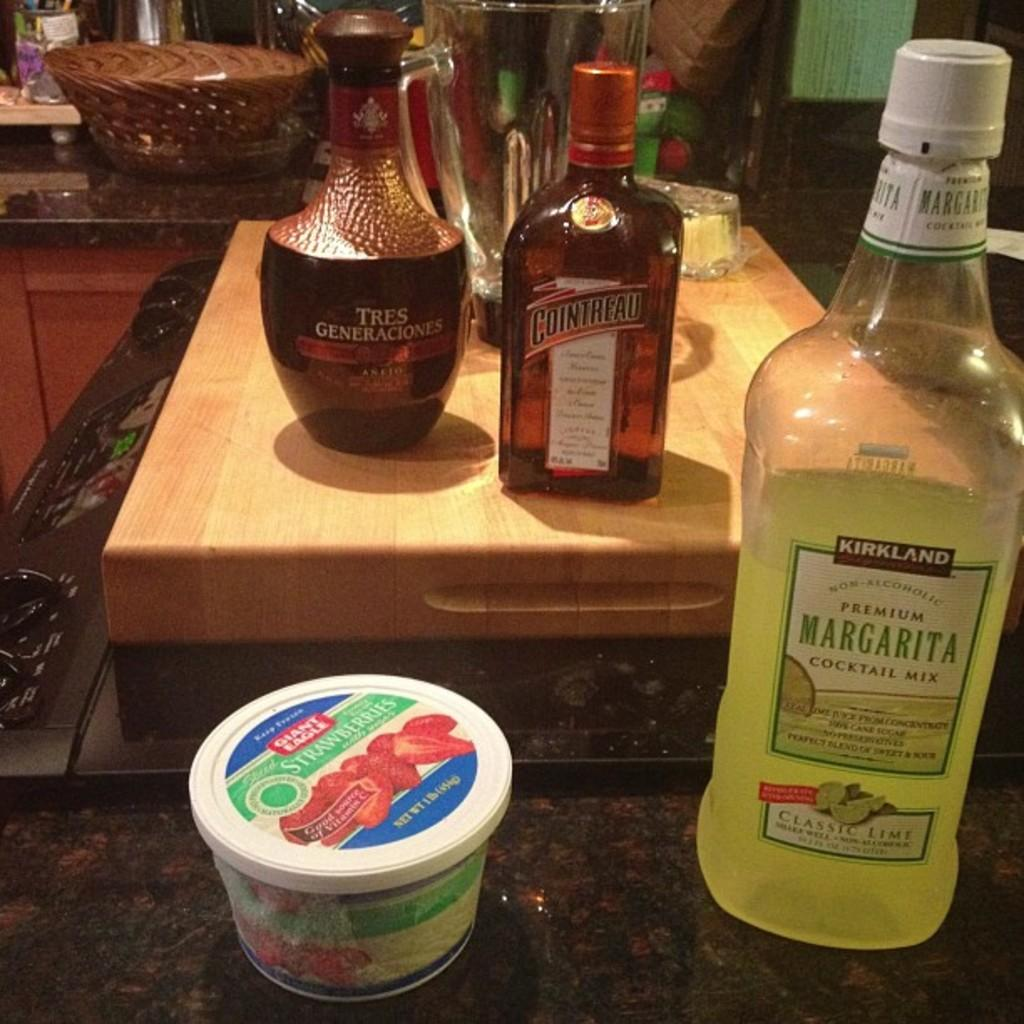<image>
Provide a brief description of the given image. A bottle of Margarita in front of a bottle of Cointreau 